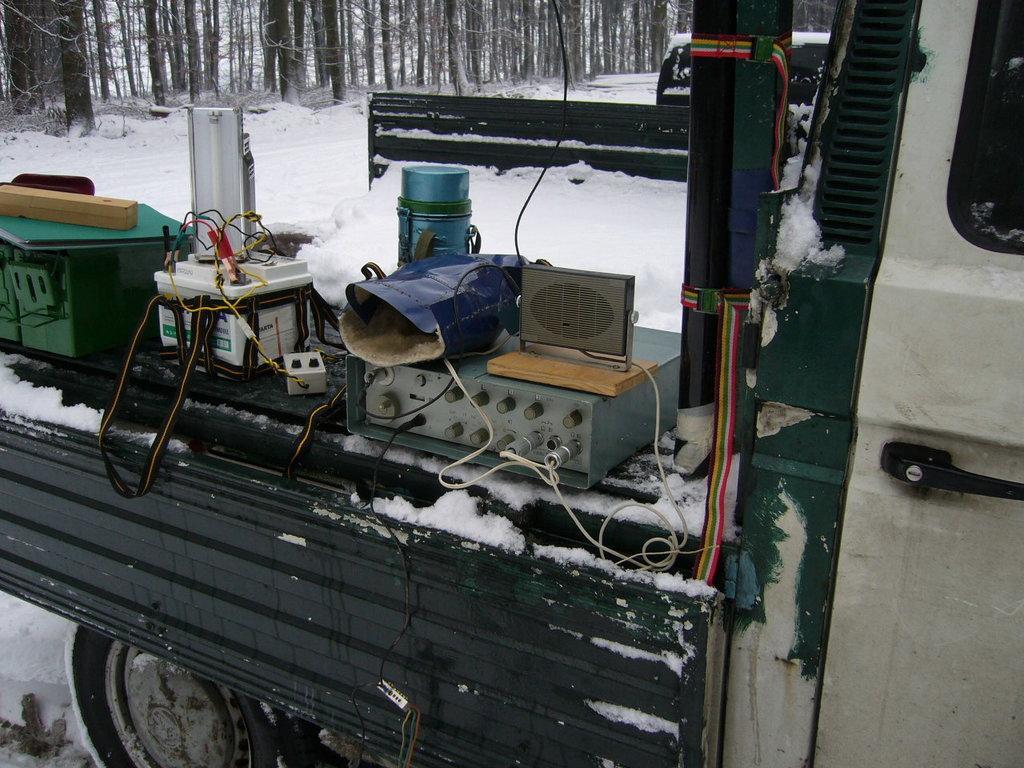Can you describe this image briefly? As we can see in the image there is a truck, electrical equipments, snow and in the background there are trees. 